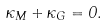Convert formula to latex. <formula><loc_0><loc_0><loc_500><loc_500>\kappa _ { M } + \kappa _ { G } = 0 .</formula> 